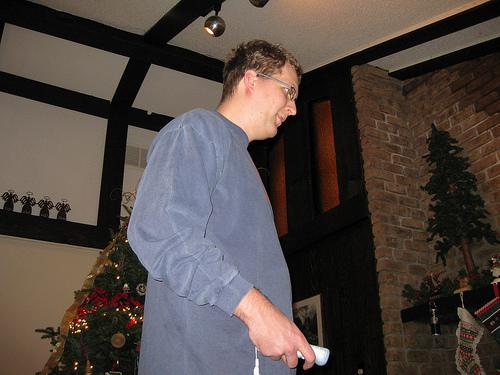Question: who is in the picture?
Choices:
A. Woman.
B. Grandfather.
C. Mother.
D. Man.
Answer with the letter. Answer: D Question: what is rhe man playing?
Choices:
A. Wii.
B. XBox.
C. Dreamcast.
D. Ps4.
Answer with the letter. Answer: A Question: when was the picture taken?
Choices:
A. Night.
B. Dusk.
C. Morning.
D. Afternoon.
Answer with the letter. Answer: A Question: how many people are pictured?
Choices:
A. 1.
B. 12.
C. 13.
D. 5.
Answer with the letter. Answer: A 